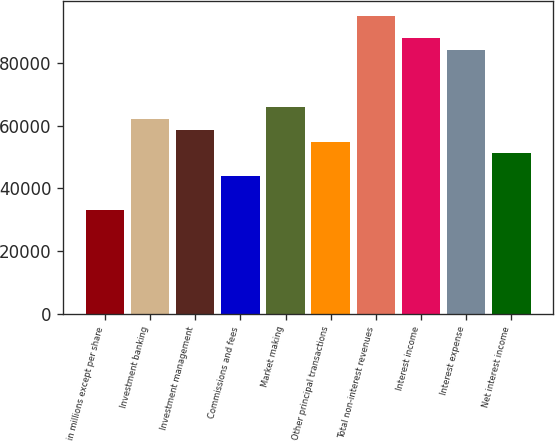Convert chart to OTSL. <chart><loc_0><loc_0><loc_500><loc_500><bar_chart><fcel>in millions except per share<fcel>Investment banking<fcel>Investment management<fcel>Commissions and fees<fcel>Market making<fcel>Other principal transactions<fcel>Total non-interest revenues<fcel>Interest income<fcel>Interest expense<fcel>Net interest income<nl><fcel>32956.9<fcel>62229.5<fcel>58570.4<fcel>43934.1<fcel>65888.5<fcel>54911.3<fcel>95161.1<fcel>87842.9<fcel>84183.9<fcel>51252.2<nl></chart> 